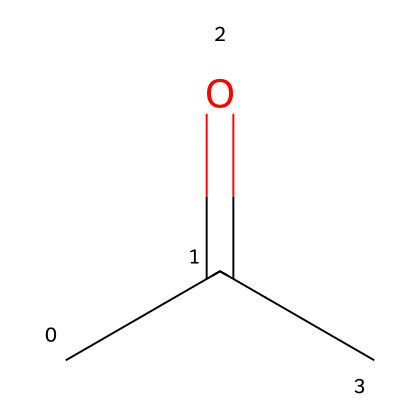What is the name of this chemical? The SMILES representation corresponds to a substance with the structure of a ketone, specifically identified as acetone based on common chemical naming conventions.
Answer: acetone How many carbon atoms are in acetone? The SMILES notation CC(=O)C shows that there are three carbon atoms (two from the 'CC' and one from 'C' after the carbonyl).
Answer: three What type of functional group is present in acetone? The structure includes a carbonyl group (C=O), which is characteristic of ketones, indicating that it has a ketone functional group.
Answer: ketone What is the total number of hydrogen atoms in acetone? Analyzing the structure, each carbon usually attaches to enough hydrogen to reach four total bonds. For acetone, there are six hydrogen atoms present when accounting for the bonding structure around the three carbon atoms.
Answer: six What is the molecular formula of acetone? By counting the number of each type of atom (3 carbons, 6 hydrogens, and 1 oxygen) based on the SMILES representation, we derive the molecular formula as C3H6O.
Answer: C3H6O Does acetone have polar or nonpolar characteristics? Given the presence of the polar carbonyl group (C=O), while acetone also has nonpolar carbon-hydrogen bonds, the molecule overall is classified as polar due to the electronegativity difference in the carbonyl group affecting molecular interactions.
Answer: polar What is the primary use of acetone? Acetone is primarily known for its use as a solvent, particularly in nail polish removers and in various industrial applications for dissolving other substances.
Answer: solvent 